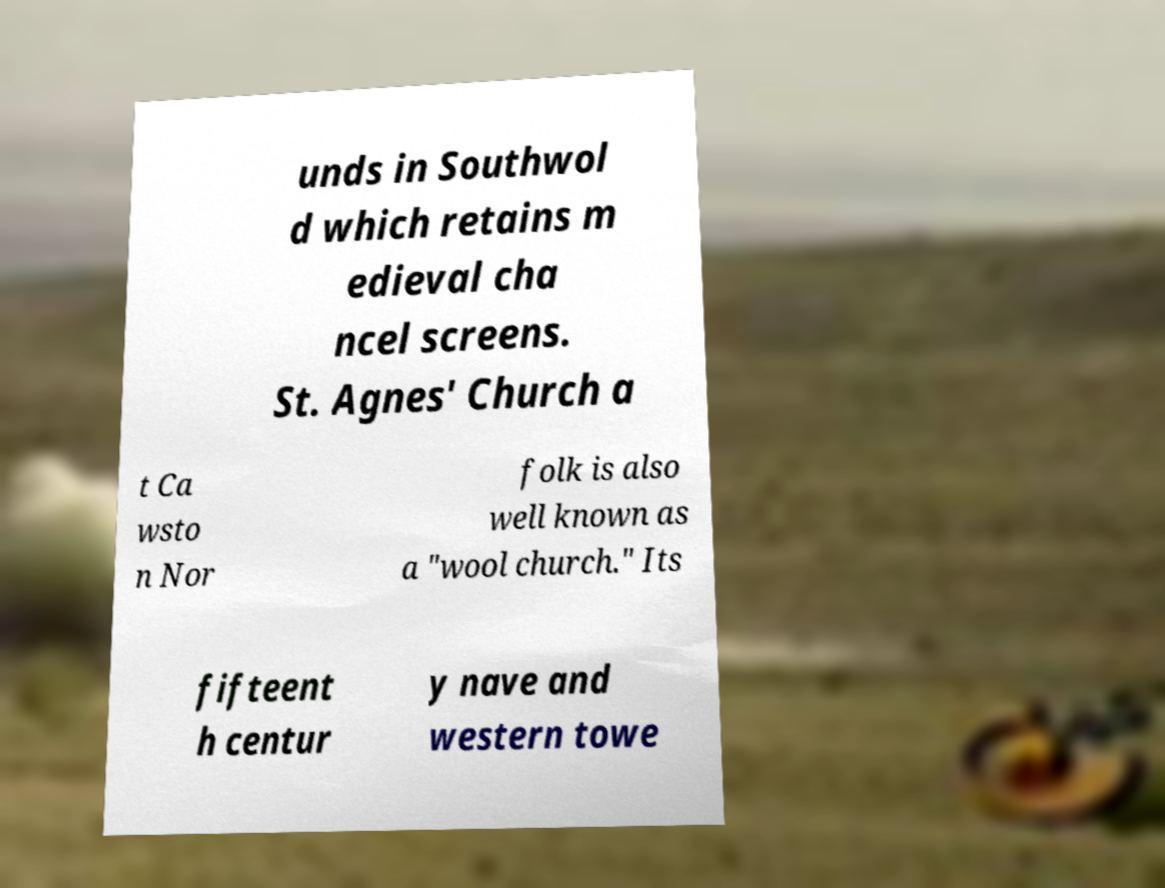I need the written content from this picture converted into text. Can you do that? unds in Southwol d which retains m edieval cha ncel screens. St. Agnes' Church a t Ca wsto n Nor folk is also well known as a "wool church." Its fifteent h centur y nave and western towe 